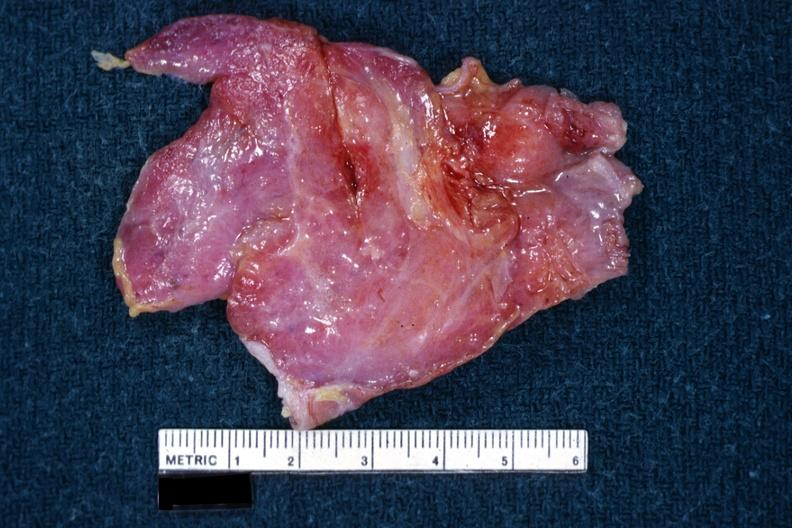s hematologic present?
Answer the question using a single word or phrase. Yes 